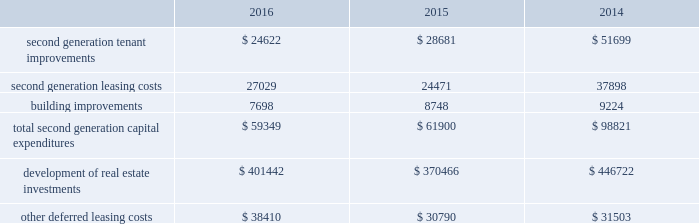Property investmentp yrr our overall strategy is to continue to increase our investment in quality industrial properties in both existing and select new markets and to continue to increase our investment in on-campus or hospital affiliated medical offf fice ff properties .
Pursuant to this strategy , we evaluate development and acquisition opportunities based upon our market yy outlook , including general economic conditions , supply and long-term growth potential .
Our ability to make future property investments is dependent upon identifying suitable acquisition and development opportunities , and our continued access to our longer-term sources of liquidity , including issuances of debt or equity securities as well asyy generating cash flow by disposing of selected properties .
Leasing/capital costsg p tenant improvements and lease-related costs pertaining to our initial leasing of newly completed space , or vacant tt space in acquired properties , are referred to as first generation expenditures .
Such first generation expenditures for tenant improvements are included within "development of real estate investments" in our consolidated statements of cash flows , while such expenditures for lease-related costs are included within "other deferred leasing costs." cash expenditures related to the construction of a building's shell , as well as the associated site improvements , are also included within "development of real estate investments" in our consolidated statements of cash flows .
Tenant improvements and leasing costs to re-let rental space that we previously leased to tenants are referred to as tt second generation expenditures .
Building improvements that are not specific to any tenant , but serve to improve integral components of our real estate properties , are also second generation expenditures .
One of the principal uses of our liquidity is to fund the second generation leasing/capital expenditures of our real estate investments .
The table summarizes our second generation capital expenditures by type of expenditure , as well as capital expenditures for the development of real estate investments and for other deferred leasing costs ( in thousands ) : .
Second generation capital expenditures were significantly lower during 2016 and 2015 , compared to 2014 , as the result of significant dispositions of office properties , which were more capital intensive to re-lease than industrial ff properties .
We had wholly owned properties under development with an expected cost of ww $ 713.1 million at december 31 , 2016 , compared to projects with an expected cost of $ 599.8 million and $ 470.2 million at december 31 , 2015 and 2014 , respectively .
The capital expenditures in the table above include the capitalization of internal overhead costs .
We capitalized ww $ 24.0 million , $ 21.7 million and $ 23.9 million of overhead costs related to leasing activities , including both first and second generation leases , during the years ended december 31 , 2016 , 2015 and 2014 , respectively .
We ww capitalized $ 25.9 million , $ 23.8 million and $ 28.8 million of overhead costs related to development activities , including both development and tenant improvement projects on first and second generation space , during the years ended december 31 , 2016 , 2015 and 2014 , respectively .
Combined overhead costs capitalized to leasing and development totaled 33.5% ( 33.5 % ) , 29.0% ( 29.0 % ) and 31.4% ( 31.4 % ) of our overall pool of overhead costs at december 31 , 2016 , 2015 and 2014 , respectively .
Further discussion of the capitalization of overhead costs can be found in the year-to-year comparisons of general and administrative expenses and critical accounting policies sections of this item 7. .
What was the total costs associated with development and tenant improvement projects on first and second generation space capitalized from 2014 to 2016? 
Computations: (23.8 + (25.9 + 28.8))
Answer: 78.5. 